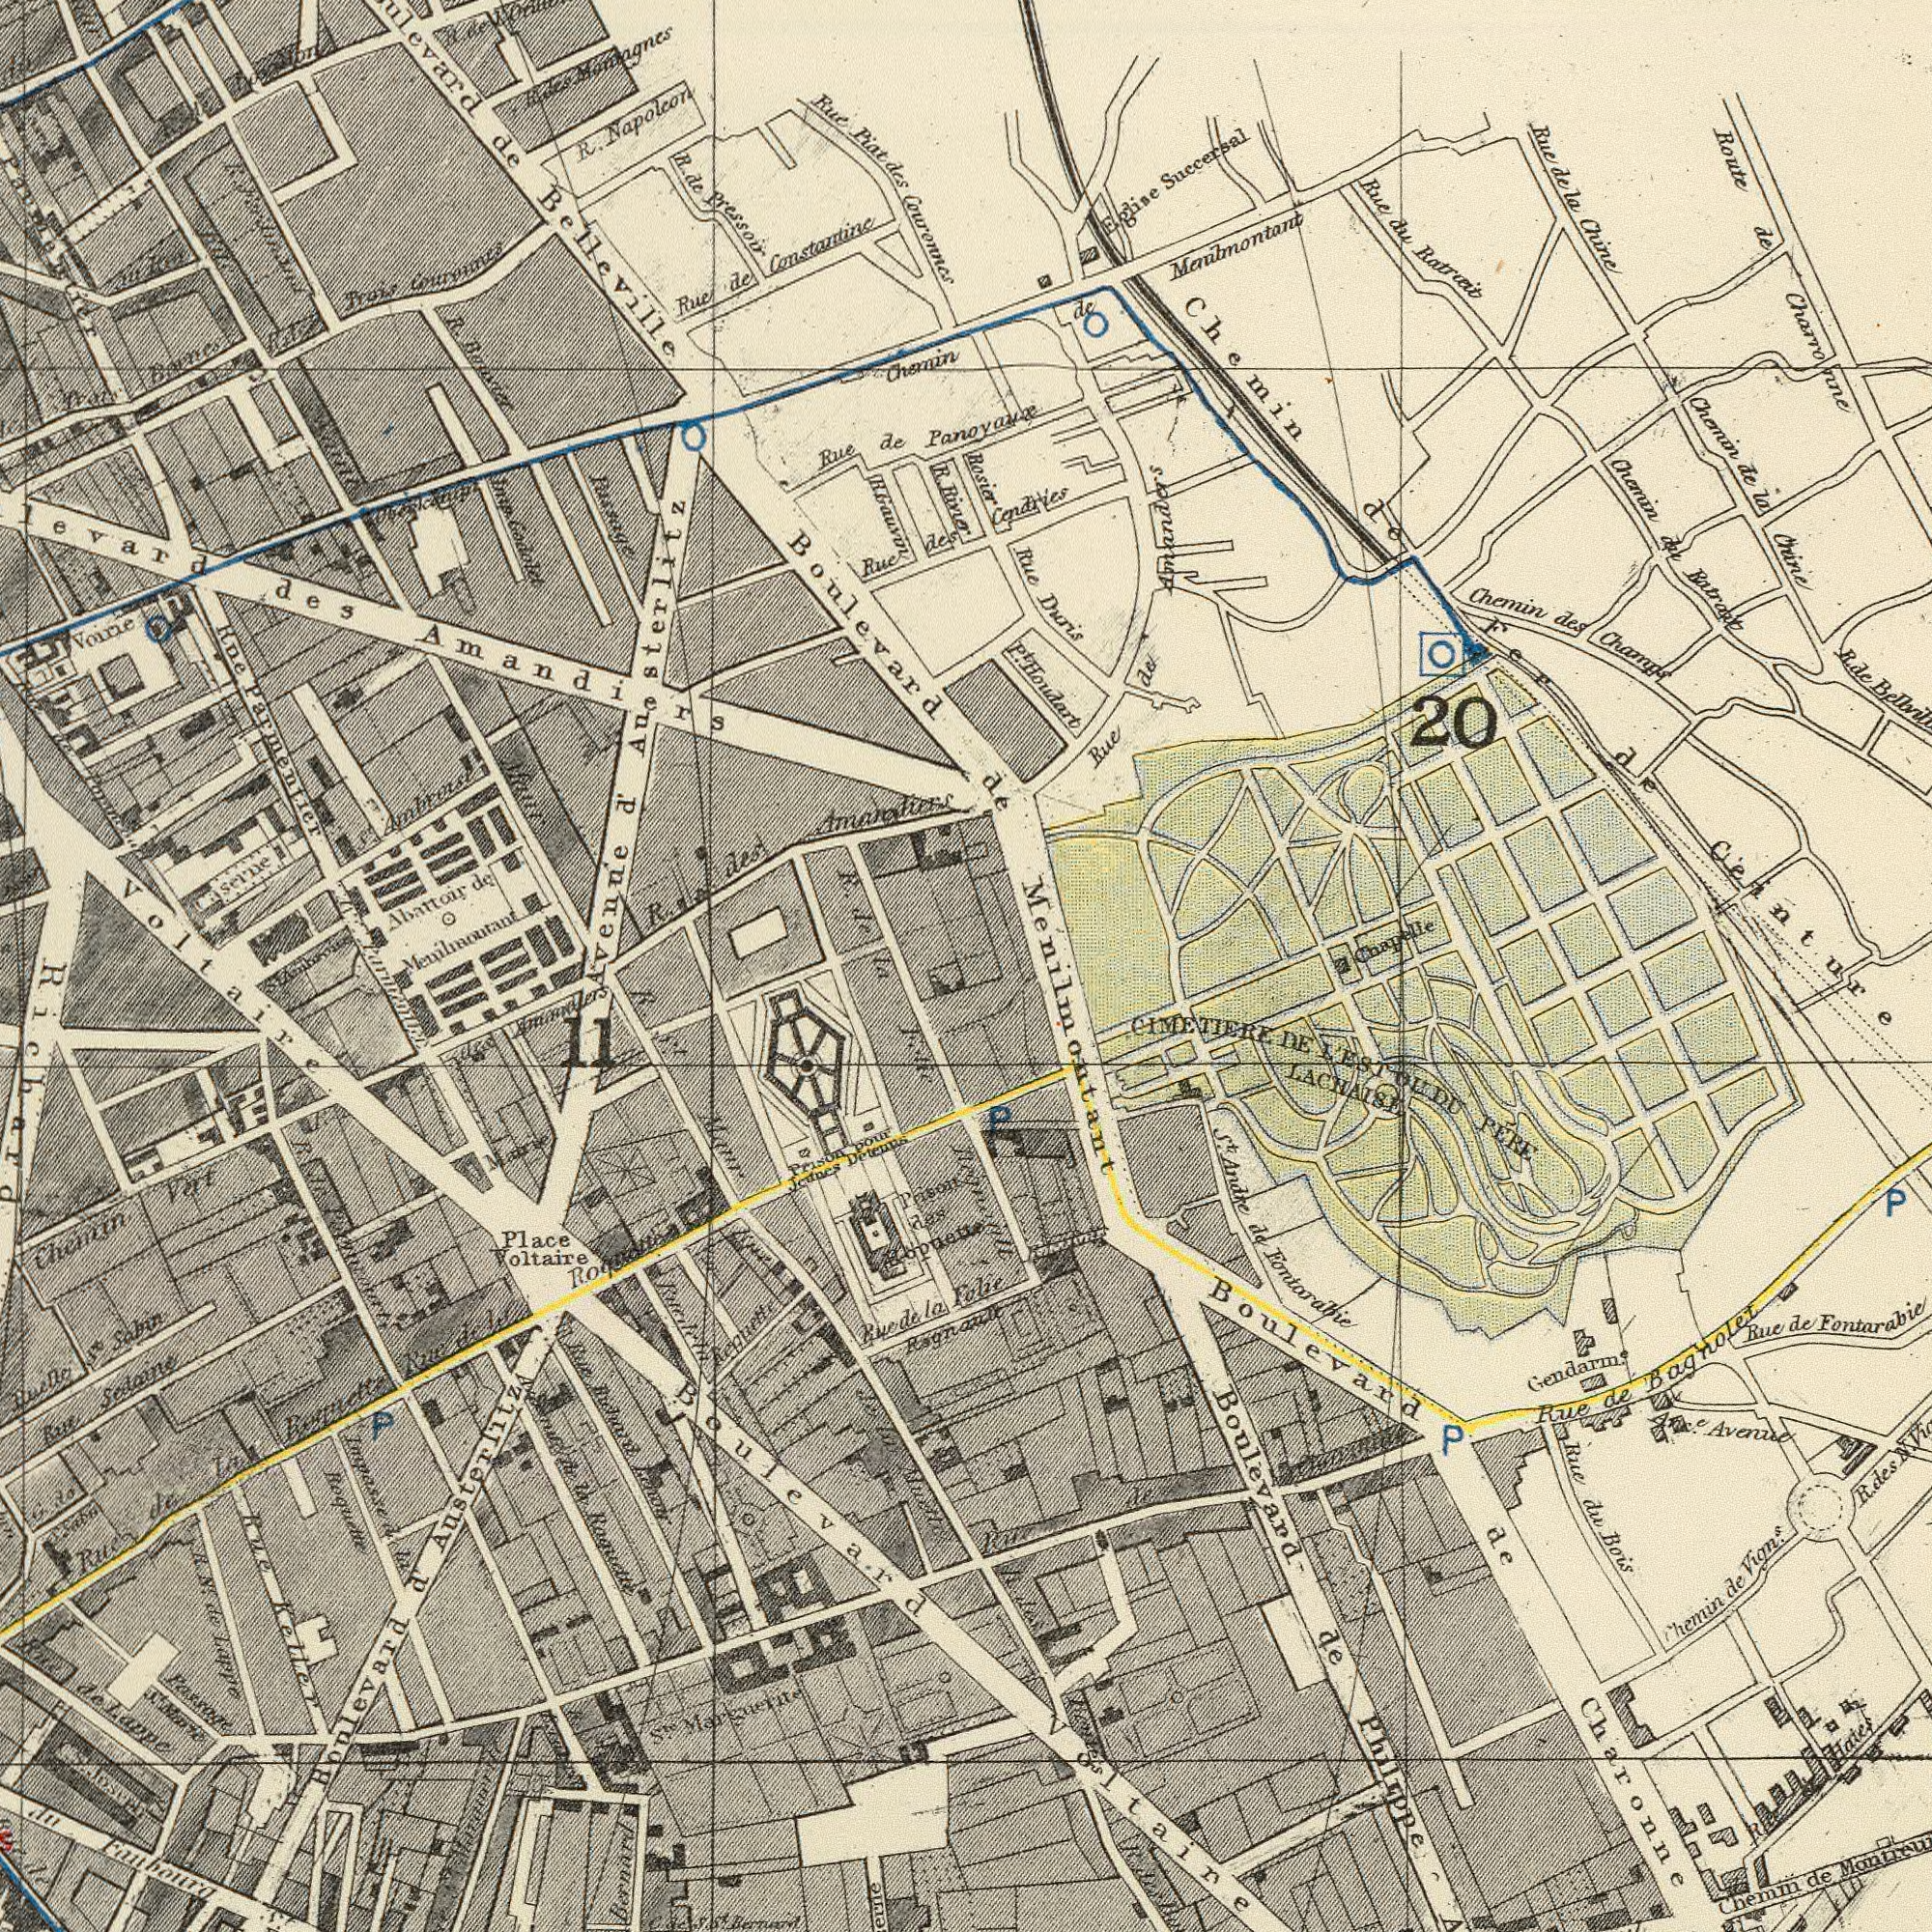What text is visible in the upper-left corner? Amandiers Couronnes Pressoir Constantine R. Parmenfier Rue Napolcon de Chemin de Rue Belleville Boulevard Courennes Voine R. Gouvin de Avenue Prais Abattoir des Rue Barnes de des Rue R. des River Piat Passage Serue R. Godolet R. Imp des Menilmoutant de d' Austerlitz Rue ###r ln Rue de R. R. R. R. de des R. R. de Rue S<sup>t</sup>. Rue What text is visible in the lower-left corner? Voltaire ###ud Chemin Sedaine Voltaire Place Rue Sabin Boulevard Raquette 11 Austerlitz Rue des Rue S<sup>t</sup>. de la Lappe la d Keguette Maur Roquette do Lappe Vert Rue Boulevard Passage S<sup>t</sup>. Keller ###opue### R. de Richard Impassed R Aluett Bernard du Sabe Faubourg CS. Rue la Marie Prison S<sup>t</sup>. des S<sup>t</sup>. de N . de la C. P Rue Rue R. Rue de le Rue de la Rue de de la de Rue S<sup>t</sup>. Jpseph Des What text appears in the top-right area of the image? Menilmontant Ceinture Chemin de Houdart Ratrait Batract Chemin Rue Chine de Succersal Champs Cendries Route Rue Rue des Chine de Chemin Duris du Chemin Rosier du 20 Chapelle de de Amanders de Charronne la de la Fer Eglise Rue de Pt. de R. What text can you see in the bottom-right section? Philippe Fontarabie CIMETIERE LACHAISE LESTOUDU Boulevard Charonne Fontarabie Gendarme. Rue Avenue de PERE Rue Bois Chemin Vigns. de de DE de S<sup>t</sup>. de Chemin Bagnolet du de VoItaire P Andre Haies R. Folie ###tes de P de Boulevard Rue P Menilmontant Rue Arce. des N. de R. R. des 